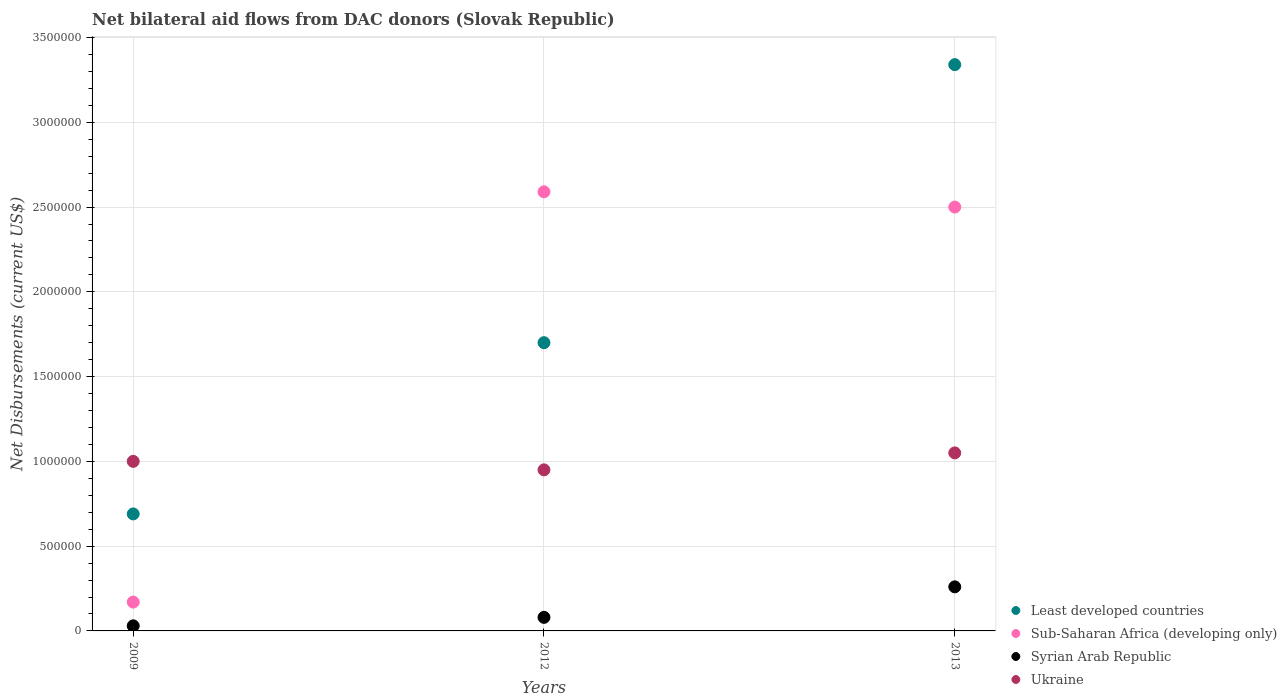How many different coloured dotlines are there?
Your response must be concise. 4. Is the number of dotlines equal to the number of legend labels?
Offer a terse response. Yes. What is the net bilateral aid flows in Syrian Arab Republic in 2009?
Offer a terse response. 3.00e+04. Across all years, what is the maximum net bilateral aid flows in Ukraine?
Provide a short and direct response. 1.05e+06. Across all years, what is the minimum net bilateral aid flows in Sub-Saharan Africa (developing only)?
Provide a succinct answer. 1.70e+05. What is the total net bilateral aid flows in Ukraine in the graph?
Make the answer very short. 3.00e+06. What is the difference between the net bilateral aid flows in Least developed countries in 2012 and that in 2013?
Ensure brevity in your answer.  -1.64e+06. What is the difference between the net bilateral aid flows in Ukraine in 2009 and the net bilateral aid flows in Syrian Arab Republic in 2012?
Your answer should be very brief. 9.20e+05. In the year 2012, what is the difference between the net bilateral aid flows in Sub-Saharan Africa (developing only) and net bilateral aid flows in Ukraine?
Give a very brief answer. 1.64e+06. In how many years, is the net bilateral aid flows in Syrian Arab Republic greater than 1800000 US$?
Your answer should be very brief. 0. What is the ratio of the net bilateral aid flows in Ukraine in 2012 to that in 2013?
Ensure brevity in your answer.  0.9. Is the difference between the net bilateral aid flows in Sub-Saharan Africa (developing only) in 2009 and 2013 greater than the difference between the net bilateral aid flows in Ukraine in 2009 and 2013?
Keep it short and to the point. No. What is the difference between the highest and the second highest net bilateral aid flows in Syrian Arab Republic?
Give a very brief answer. 1.80e+05. What is the difference between the highest and the lowest net bilateral aid flows in Sub-Saharan Africa (developing only)?
Offer a very short reply. 2.42e+06. Is it the case that in every year, the sum of the net bilateral aid flows in Syrian Arab Republic and net bilateral aid flows in Sub-Saharan Africa (developing only)  is greater than the sum of net bilateral aid flows in Least developed countries and net bilateral aid flows in Ukraine?
Offer a very short reply. No. Is it the case that in every year, the sum of the net bilateral aid flows in Least developed countries and net bilateral aid flows in Ukraine  is greater than the net bilateral aid flows in Sub-Saharan Africa (developing only)?
Ensure brevity in your answer.  Yes. What is the difference between two consecutive major ticks on the Y-axis?
Keep it short and to the point. 5.00e+05. Are the values on the major ticks of Y-axis written in scientific E-notation?
Offer a very short reply. No. Does the graph contain grids?
Your answer should be very brief. Yes. Where does the legend appear in the graph?
Offer a terse response. Bottom right. How many legend labels are there?
Give a very brief answer. 4. How are the legend labels stacked?
Provide a short and direct response. Vertical. What is the title of the graph?
Your response must be concise. Net bilateral aid flows from DAC donors (Slovak Republic). Does "Upper middle income" appear as one of the legend labels in the graph?
Provide a succinct answer. No. What is the label or title of the X-axis?
Ensure brevity in your answer.  Years. What is the label or title of the Y-axis?
Provide a short and direct response. Net Disbursements (current US$). What is the Net Disbursements (current US$) in Least developed countries in 2009?
Provide a short and direct response. 6.90e+05. What is the Net Disbursements (current US$) of Sub-Saharan Africa (developing only) in 2009?
Your answer should be compact. 1.70e+05. What is the Net Disbursements (current US$) of Least developed countries in 2012?
Your answer should be compact. 1.70e+06. What is the Net Disbursements (current US$) in Sub-Saharan Africa (developing only) in 2012?
Provide a succinct answer. 2.59e+06. What is the Net Disbursements (current US$) of Ukraine in 2012?
Offer a terse response. 9.50e+05. What is the Net Disbursements (current US$) of Least developed countries in 2013?
Your answer should be compact. 3.34e+06. What is the Net Disbursements (current US$) of Sub-Saharan Africa (developing only) in 2013?
Your answer should be very brief. 2.50e+06. What is the Net Disbursements (current US$) in Ukraine in 2013?
Offer a terse response. 1.05e+06. Across all years, what is the maximum Net Disbursements (current US$) in Least developed countries?
Provide a succinct answer. 3.34e+06. Across all years, what is the maximum Net Disbursements (current US$) in Sub-Saharan Africa (developing only)?
Offer a terse response. 2.59e+06. Across all years, what is the maximum Net Disbursements (current US$) of Syrian Arab Republic?
Your answer should be very brief. 2.60e+05. Across all years, what is the maximum Net Disbursements (current US$) of Ukraine?
Offer a terse response. 1.05e+06. Across all years, what is the minimum Net Disbursements (current US$) in Least developed countries?
Your answer should be very brief. 6.90e+05. Across all years, what is the minimum Net Disbursements (current US$) in Sub-Saharan Africa (developing only)?
Offer a terse response. 1.70e+05. Across all years, what is the minimum Net Disbursements (current US$) of Ukraine?
Offer a terse response. 9.50e+05. What is the total Net Disbursements (current US$) of Least developed countries in the graph?
Offer a terse response. 5.73e+06. What is the total Net Disbursements (current US$) of Sub-Saharan Africa (developing only) in the graph?
Offer a very short reply. 5.26e+06. What is the total Net Disbursements (current US$) in Syrian Arab Republic in the graph?
Provide a succinct answer. 3.70e+05. What is the difference between the Net Disbursements (current US$) of Least developed countries in 2009 and that in 2012?
Give a very brief answer. -1.01e+06. What is the difference between the Net Disbursements (current US$) of Sub-Saharan Africa (developing only) in 2009 and that in 2012?
Your answer should be compact. -2.42e+06. What is the difference between the Net Disbursements (current US$) in Syrian Arab Republic in 2009 and that in 2012?
Provide a succinct answer. -5.00e+04. What is the difference between the Net Disbursements (current US$) in Ukraine in 2009 and that in 2012?
Your response must be concise. 5.00e+04. What is the difference between the Net Disbursements (current US$) in Least developed countries in 2009 and that in 2013?
Your response must be concise. -2.65e+06. What is the difference between the Net Disbursements (current US$) in Sub-Saharan Africa (developing only) in 2009 and that in 2013?
Offer a very short reply. -2.33e+06. What is the difference between the Net Disbursements (current US$) of Syrian Arab Republic in 2009 and that in 2013?
Provide a succinct answer. -2.30e+05. What is the difference between the Net Disbursements (current US$) in Least developed countries in 2012 and that in 2013?
Keep it short and to the point. -1.64e+06. What is the difference between the Net Disbursements (current US$) in Sub-Saharan Africa (developing only) in 2012 and that in 2013?
Offer a terse response. 9.00e+04. What is the difference between the Net Disbursements (current US$) of Syrian Arab Republic in 2012 and that in 2013?
Your answer should be compact. -1.80e+05. What is the difference between the Net Disbursements (current US$) of Ukraine in 2012 and that in 2013?
Make the answer very short. -1.00e+05. What is the difference between the Net Disbursements (current US$) in Least developed countries in 2009 and the Net Disbursements (current US$) in Sub-Saharan Africa (developing only) in 2012?
Ensure brevity in your answer.  -1.90e+06. What is the difference between the Net Disbursements (current US$) of Least developed countries in 2009 and the Net Disbursements (current US$) of Syrian Arab Republic in 2012?
Offer a very short reply. 6.10e+05. What is the difference between the Net Disbursements (current US$) of Least developed countries in 2009 and the Net Disbursements (current US$) of Ukraine in 2012?
Offer a terse response. -2.60e+05. What is the difference between the Net Disbursements (current US$) in Sub-Saharan Africa (developing only) in 2009 and the Net Disbursements (current US$) in Ukraine in 2012?
Provide a succinct answer. -7.80e+05. What is the difference between the Net Disbursements (current US$) of Syrian Arab Republic in 2009 and the Net Disbursements (current US$) of Ukraine in 2012?
Give a very brief answer. -9.20e+05. What is the difference between the Net Disbursements (current US$) of Least developed countries in 2009 and the Net Disbursements (current US$) of Sub-Saharan Africa (developing only) in 2013?
Provide a succinct answer. -1.81e+06. What is the difference between the Net Disbursements (current US$) of Least developed countries in 2009 and the Net Disbursements (current US$) of Syrian Arab Republic in 2013?
Provide a succinct answer. 4.30e+05. What is the difference between the Net Disbursements (current US$) in Least developed countries in 2009 and the Net Disbursements (current US$) in Ukraine in 2013?
Provide a succinct answer. -3.60e+05. What is the difference between the Net Disbursements (current US$) in Sub-Saharan Africa (developing only) in 2009 and the Net Disbursements (current US$) in Syrian Arab Republic in 2013?
Offer a very short reply. -9.00e+04. What is the difference between the Net Disbursements (current US$) in Sub-Saharan Africa (developing only) in 2009 and the Net Disbursements (current US$) in Ukraine in 2013?
Ensure brevity in your answer.  -8.80e+05. What is the difference between the Net Disbursements (current US$) of Syrian Arab Republic in 2009 and the Net Disbursements (current US$) of Ukraine in 2013?
Ensure brevity in your answer.  -1.02e+06. What is the difference between the Net Disbursements (current US$) in Least developed countries in 2012 and the Net Disbursements (current US$) in Sub-Saharan Africa (developing only) in 2013?
Keep it short and to the point. -8.00e+05. What is the difference between the Net Disbursements (current US$) in Least developed countries in 2012 and the Net Disbursements (current US$) in Syrian Arab Republic in 2013?
Provide a succinct answer. 1.44e+06. What is the difference between the Net Disbursements (current US$) in Least developed countries in 2012 and the Net Disbursements (current US$) in Ukraine in 2013?
Make the answer very short. 6.50e+05. What is the difference between the Net Disbursements (current US$) in Sub-Saharan Africa (developing only) in 2012 and the Net Disbursements (current US$) in Syrian Arab Republic in 2013?
Offer a terse response. 2.33e+06. What is the difference between the Net Disbursements (current US$) of Sub-Saharan Africa (developing only) in 2012 and the Net Disbursements (current US$) of Ukraine in 2013?
Your answer should be very brief. 1.54e+06. What is the difference between the Net Disbursements (current US$) in Syrian Arab Republic in 2012 and the Net Disbursements (current US$) in Ukraine in 2013?
Your response must be concise. -9.70e+05. What is the average Net Disbursements (current US$) in Least developed countries per year?
Ensure brevity in your answer.  1.91e+06. What is the average Net Disbursements (current US$) in Sub-Saharan Africa (developing only) per year?
Provide a succinct answer. 1.75e+06. What is the average Net Disbursements (current US$) of Syrian Arab Republic per year?
Your answer should be compact. 1.23e+05. What is the average Net Disbursements (current US$) of Ukraine per year?
Provide a succinct answer. 1.00e+06. In the year 2009, what is the difference between the Net Disbursements (current US$) in Least developed countries and Net Disbursements (current US$) in Sub-Saharan Africa (developing only)?
Provide a short and direct response. 5.20e+05. In the year 2009, what is the difference between the Net Disbursements (current US$) in Least developed countries and Net Disbursements (current US$) in Ukraine?
Make the answer very short. -3.10e+05. In the year 2009, what is the difference between the Net Disbursements (current US$) in Sub-Saharan Africa (developing only) and Net Disbursements (current US$) in Syrian Arab Republic?
Offer a very short reply. 1.40e+05. In the year 2009, what is the difference between the Net Disbursements (current US$) in Sub-Saharan Africa (developing only) and Net Disbursements (current US$) in Ukraine?
Offer a terse response. -8.30e+05. In the year 2009, what is the difference between the Net Disbursements (current US$) of Syrian Arab Republic and Net Disbursements (current US$) of Ukraine?
Give a very brief answer. -9.70e+05. In the year 2012, what is the difference between the Net Disbursements (current US$) of Least developed countries and Net Disbursements (current US$) of Sub-Saharan Africa (developing only)?
Give a very brief answer. -8.90e+05. In the year 2012, what is the difference between the Net Disbursements (current US$) of Least developed countries and Net Disbursements (current US$) of Syrian Arab Republic?
Provide a short and direct response. 1.62e+06. In the year 2012, what is the difference between the Net Disbursements (current US$) in Least developed countries and Net Disbursements (current US$) in Ukraine?
Offer a terse response. 7.50e+05. In the year 2012, what is the difference between the Net Disbursements (current US$) in Sub-Saharan Africa (developing only) and Net Disbursements (current US$) in Syrian Arab Republic?
Provide a succinct answer. 2.51e+06. In the year 2012, what is the difference between the Net Disbursements (current US$) in Sub-Saharan Africa (developing only) and Net Disbursements (current US$) in Ukraine?
Provide a short and direct response. 1.64e+06. In the year 2012, what is the difference between the Net Disbursements (current US$) of Syrian Arab Republic and Net Disbursements (current US$) of Ukraine?
Your answer should be compact. -8.70e+05. In the year 2013, what is the difference between the Net Disbursements (current US$) in Least developed countries and Net Disbursements (current US$) in Sub-Saharan Africa (developing only)?
Offer a very short reply. 8.40e+05. In the year 2013, what is the difference between the Net Disbursements (current US$) in Least developed countries and Net Disbursements (current US$) in Syrian Arab Republic?
Make the answer very short. 3.08e+06. In the year 2013, what is the difference between the Net Disbursements (current US$) of Least developed countries and Net Disbursements (current US$) of Ukraine?
Your answer should be compact. 2.29e+06. In the year 2013, what is the difference between the Net Disbursements (current US$) of Sub-Saharan Africa (developing only) and Net Disbursements (current US$) of Syrian Arab Republic?
Your response must be concise. 2.24e+06. In the year 2013, what is the difference between the Net Disbursements (current US$) in Sub-Saharan Africa (developing only) and Net Disbursements (current US$) in Ukraine?
Provide a short and direct response. 1.45e+06. In the year 2013, what is the difference between the Net Disbursements (current US$) in Syrian Arab Republic and Net Disbursements (current US$) in Ukraine?
Give a very brief answer. -7.90e+05. What is the ratio of the Net Disbursements (current US$) in Least developed countries in 2009 to that in 2012?
Your answer should be very brief. 0.41. What is the ratio of the Net Disbursements (current US$) in Sub-Saharan Africa (developing only) in 2009 to that in 2012?
Give a very brief answer. 0.07. What is the ratio of the Net Disbursements (current US$) of Syrian Arab Republic in 2009 to that in 2012?
Keep it short and to the point. 0.38. What is the ratio of the Net Disbursements (current US$) of Ukraine in 2009 to that in 2012?
Provide a succinct answer. 1.05. What is the ratio of the Net Disbursements (current US$) in Least developed countries in 2009 to that in 2013?
Give a very brief answer. 0.21. What is the ratio of the Net Disbursements (current US$) of Sub-Saharan Africa (developing only) in 2009 to that in 2013?
Provide a short and direct response. 0.07. What is the ratio of the Net Disbursements (current US$) in Syrian Arab Republic in 2009 to that in 2013?
Make the answer very short. 0.12. What is the ratio of the Net Disbursements (current US$) of Least developed countries in 2012 to that in 2013?
Your answer should be compact. 0.51. What is the ratio of the Net Disbursements (current US$) of Sub-Saharan Africa (developing only) in 2012 to that in 2013?
Make the answer very short. 1.04. What is the ratio of the Net Disbursements (current US$) of Syrian Arab Republic in 2012 to that in 2013?
Your response must be concise. 0.31. What is the ratio of the Net Disbursements (current US$) in Ukraine in 2012 to that in 2013?
Give a very brief answer. 0.9. What is the difference between the highest and the second highest Net Disbursements (current US$) of Least developed countries?
Your response must be concise. 1.64e+06. What is the difference between the highest and the lowest Net Disbursements (current US$) in Least developed countries?
Provide a short and direct response. 2.65e+06. What is the difference between the highest and the lowest Net Disbursements (current US$) in Sub-Saharan Africa (developing only)?
Make the answer very short. 2.42e+06. What is the difference between the highest and the lowest Net Disbursements (current US$) in Syrian Arab Republic?
Your response must be concise. 2.30e+05. 